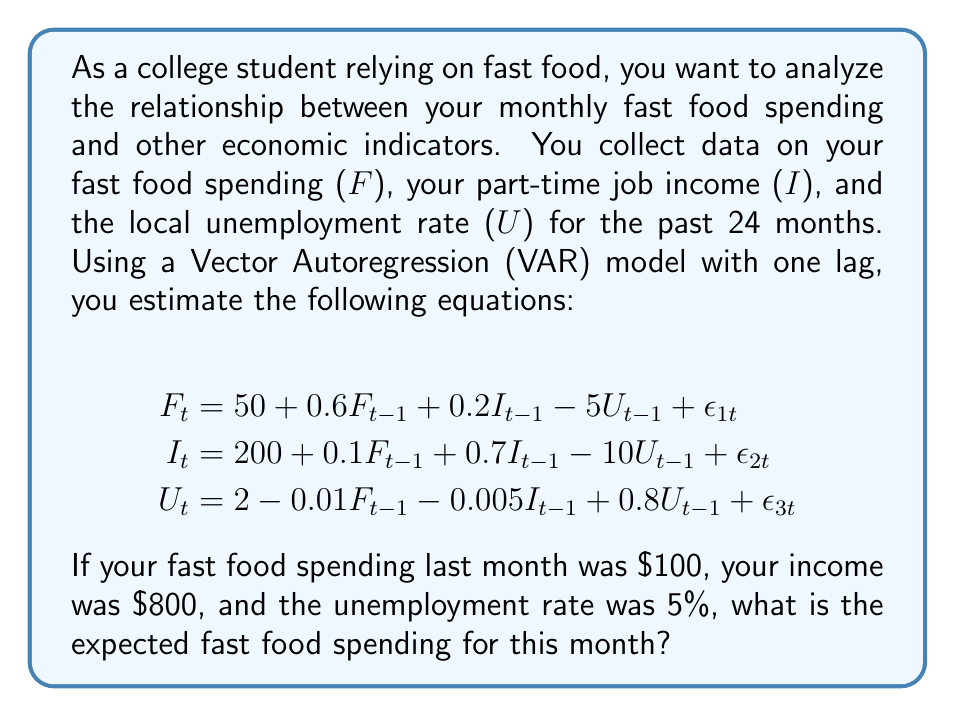Give your solution to this math problem. To solve this problem, we need to use the first equation of the VAR model, which represents the fast food spending:

$$F_t = 50 + 0.6F_{t-1} + 0.2I_{t-1} - 5U_{t-1} + \epsilon_{1t}$$

We have the following values for the previous month (t-1):
- $F_{t-1} = 100$ (fast food spending)
- $I_{t-1} = 800$ (income)
- $U_{t-1} = 5\%$ (unemployment rate)

Let's substitute these values into the equation:

$$\begin{aligned}
F_t &= 50 + 0.6(100) + 0.2(800) - 5(5) + \epsilon_{1t} \\
&= 50 + 60 + 160 - 25 + \epsilon_{1t} \\
&= 245 + \epsilon_{1t}
\end{aligned}$$

The term $\epsilon_{1t}$ represents the error or unexplained variation in the model. For forecasting purposes, we assume that the expected value of the error term is zero: $E(\epsilon_{1t}) = 0$.

Therefore, the expected fast food spending for this month is:

$$E(F_t) = 245$$
Answer: $245 